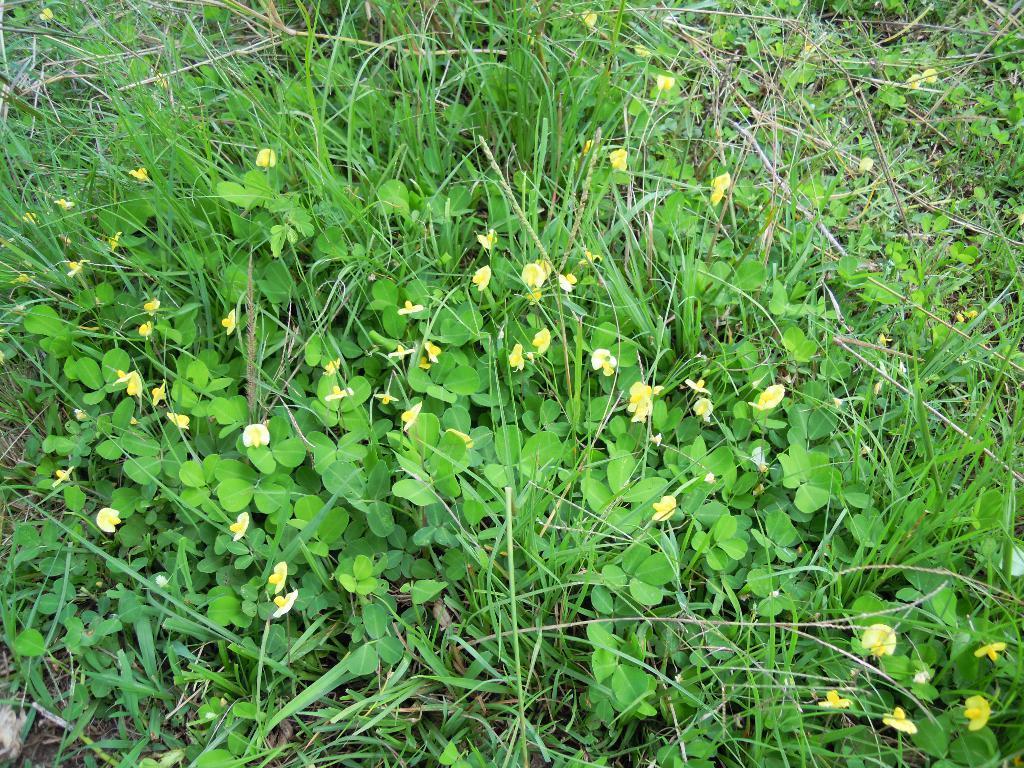Could you give a brief overview of what you see in this image? In this image, we can see some plants and grass on the ground. 